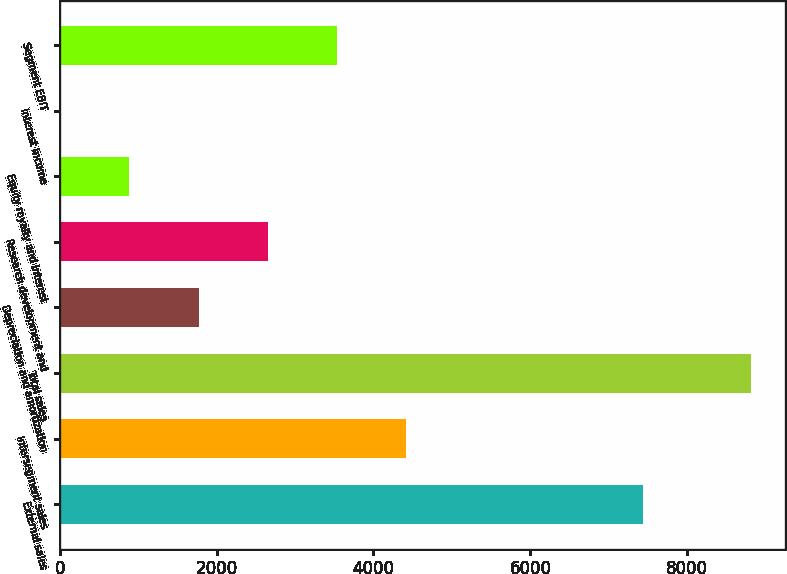Convert chart. <chart><loc_0><loc_0><loc_500><loc_500><bar_chart><fcel>External sales<fcel>Intersegment sales<fcel>Total sales<fcel>Depreciation and amortization<fcel>Research development and<fcel>Equity royalty and interest<fcel>Interest income<fcel>Segment EBIT<nl><fcel>7432<fcel>4410<fcel>8810<fcel>1770<fcel>2650<fcel>890<fcel>10<fcel>3530<nl></chart> 